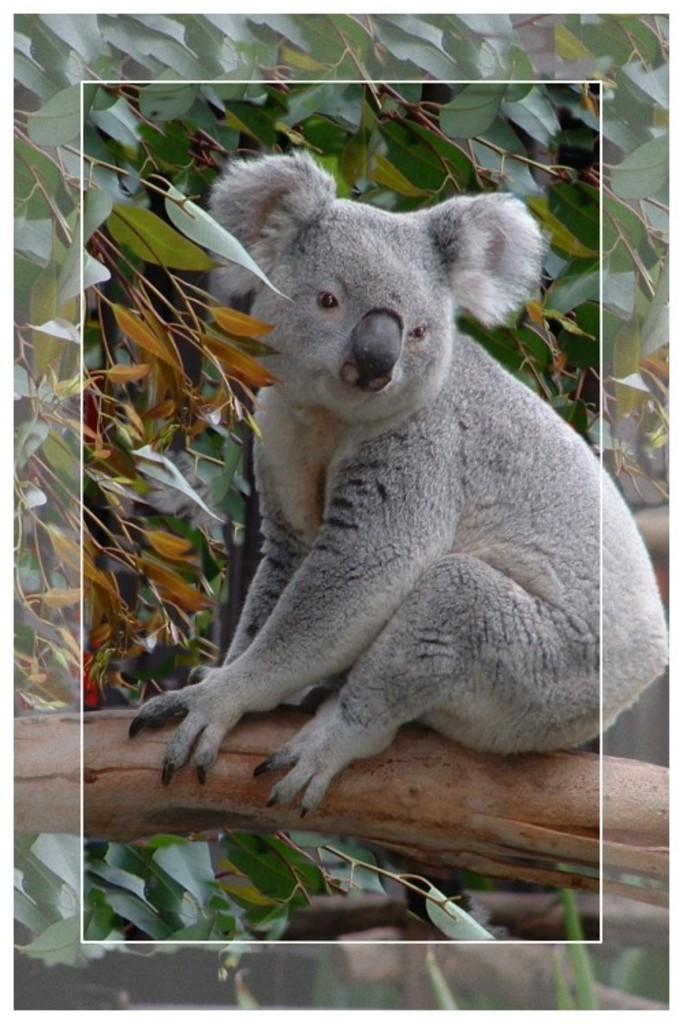What type of creature can be seen in the image? There is an animal in the image. Where is the animal located? The animal is on a branch of a tree. What else can be seen in the image besides the animal? There are leaves visible in the image. How many legs can be seen on the bottle in the image? There is no bottle present in the image, and therefore no legs can be seen on it. 